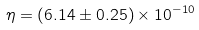Convert formula to latex. <formula><loc_0><loc_0><loc_500><loc_500>\eta = ( 6 . 1 4 \pm 0 . 2 5 ) \times 1 0 ^ { - 1 0 }</formula> 